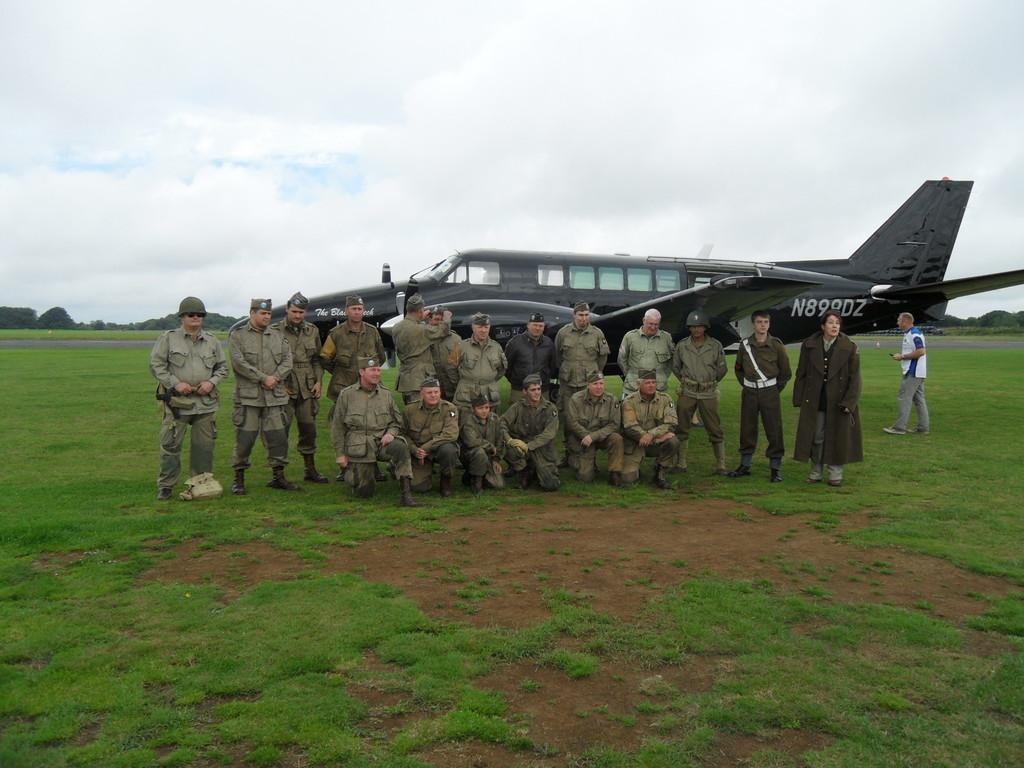Provide a one-sentence caption for the provided image. The identification numbers on the black aircraft are N899DZ. 